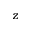Convert formula to latex. <formula><loc_0><loc_0><loc_500><loc_500>z</formula> 